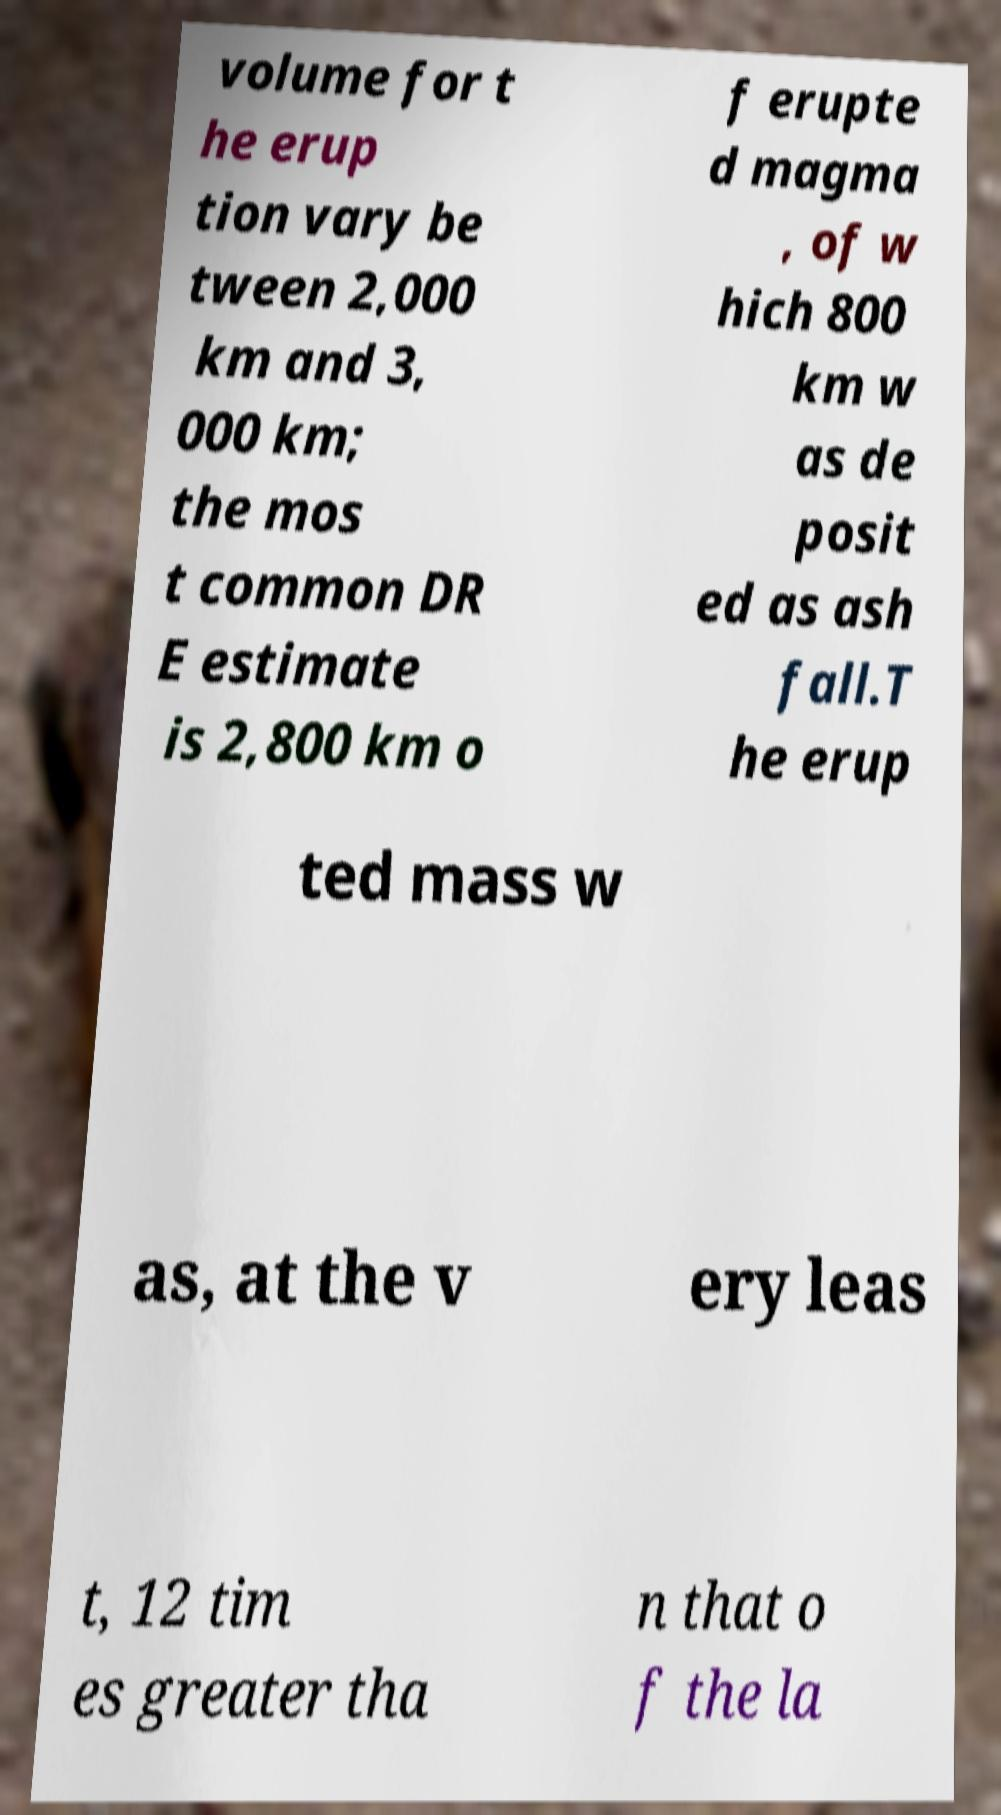Can you accurately transcribe the text from the provided image for me? volume for t he erup tion vary be tween 2,000 km and 3, 000 km; the mos t common DR E estimate is 2,800 km o f erupte d magma , of w hich 800 km w as de posit ed as ash fall.T he erup ted mass w as, at the v ery leas t, 12 tim es greater tha n that o f the la 